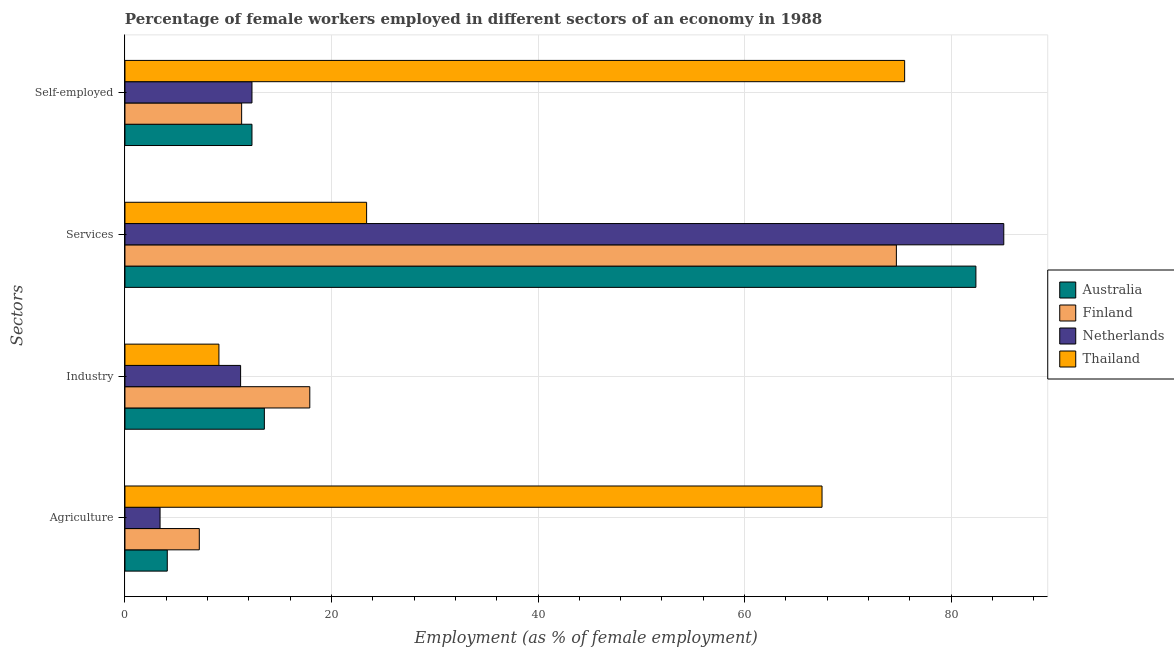Are the number of bars on each tick of the Y-axis equal?
Give a very brief answer. Yes. How many bars are there on the 4th tick from the top?
Give a very brief answer. 4. What is the label of the 2nd group of bars from the top?
Ensure brevity in your answer.  Services. What is the percentage of female workers in industry in Finland?
Keep it short and to the point. 17.9. Across all countries, what is the maximum percentage of self employed female workers?
Give a very brief answer. 75.5. Across all countries, what is the minimum percentage of self employed female workers?
Make the answer very short. 11.3. In which country was the percentage of self employed female workers maximum?
Keep it short and to the point. Thailand. What is the total percentage of self employed female workers in the graph?
Your answer should be very brief. 111.4. What is the difference between the percentage of female workers in services in Netherlands and that in Finland?
Your answer should be compact. 10.4. What is the difference between the percentage of female workers in agriculture in Australia and the percentage of female workers in industry in Thailand?
Provide a short and direct response. -5. What is the average percentage of self employed female workers per country?
Your answer should be compact. 27.85. What is the difference between the percentage of female workers in services and percentage of female workers in agriculture in Australia?
Offer a terse response. 78.3. What is the ratio of the percentage of female workers in agriculture in Australia to that in Finland?
Make the answer very short. 0.57. Is the percentage of female workers in industry in Australia less than that in Netherlands?
Keep it short and to the point. No. Is the difference between the percentage of self employed female workers in Australia and Netherlands greater than the difference between the percentage of female workers in agriculture in Australia and Netherlands?
Your answer should be compact. No. What is the difference between the highest and the second highest percentage of female workers in agriculture?
Give a very brief answer. 60.3. What is the difference between the highest and the lowest percentage of female workers in agriculture?
Offer a terse response. 64.1. Is it the case that in every country, the sum of the percentage of female workers in services and percentage of female workers in industry is greater than the sum of percentage of self employed female workers and percentage of female workers in agriculture?
Your response must be concise. Yes. What does the 3rd bar from the top in Services represents?
Ensure brevity in your answer.  Finland. What is the difference between two consecutive major ticks on the X-axis?
Provide a short and direct response. 20. Does the graph contain any zero values?
Offer a terse response. No. Does the graph contain grids?
Your answer should be compact. Yes. How many legend labels are there?
Give a very brief answer. 4. What is the title of the graph?
Provide a short and direct response. Percentage of female workers employed in different sectors of an economy in 1988. What is the label or title of the X-axis?
Offer a terse response. Employment (as % of female employment). What is the label or title of the Y-axis?
Your response must be concise. Sectors. What is the Employment (as % of female employment) of Australia in Agriculture?
Your answer should be very brief. 4.1. What is the Employment (as % of female employment) of Finland in Agriculture?
Make the answer very short. 7.2. What is the Employment (as % of female employment) of Netherlands in Agriculture?
Your answer should be compact. 3.4. What is the Employment (as % of female employment) in Thailand in Agriculture?
Offer a terse response. 67.5. What is the Employment (as % of female employment) of Finland in Industry?
Offer a very short reply. 17.9. What is the Employment (as % of female employment) of Netherlands in Industry?
Provide a succinct answer. 11.2. What is the Employment (as % of female employment) of Thailand in Industry?
Offer a terse response. 9.1. What is the Employment (as % of female employment) of Australia in Services?
Offer a terse response. 82.4. What is the Employment (as % of female employment) of Finland in Services?
Offer a very short reply. 74.7. What is the Employment (as % of female employment) in Netherlands in Services?
Your answer should be compact. 85.1. What is the Employment (as % of female employment) of Thailand in Services?
Your response must be concise. 23.4. What is the Employment (as % of female employment) of Australia in Self-employed?
Your answer should be compact. 12.3. What is the Employment (as % of female employment) of Finland in Self-employed?
Make the answer very short. 11.3. What is the Employment (as % of female employment) in Netherlands in Self-employed?
Offer a terse response. 12.3. What is the Employment (as % of female employment) of Thailand in Self-employed?
Your response must be concise. 75.5. Across all Sectors, what is the maximum Employment (as % of female employment) in Australia?
Give a very brief answer. 82.4. Across all Sectors, what is the maximum Employment (as % of female employment) in Finland?
Keep it short and to the point. 74.7. Across all Sectors, what is the maximum Employment (as % of female employment) of Netherlands?
Give a very brief answer. 85.1. Across all Sectors, what is the maximum Employment (as % of female employment) of Thailand?
Your answer should be compact. 75.5. Across all Sectors, what is the minimum Employment (as % of female employment) of Australia?
Ensure brevity in your answer.  4.1. Across all Sectors, what is the minimum Employment (as % of female employment) in Finland?
Offer a terse response. 7.2. Across all Sectors, what is the minimum Employment (as % of female employment) in Netherlands?
Ensure brevity in your answer.  3.4. Across all Sectors, what is the minimum Employment (as % of female employment) of Thailand?
Offer a very short reply. 9.1. What is the total Employment (as % of female employment) in Australia in the graph?
Provide a succinct answer. 112.3. What is the total Employment (as % of female employment) of Finland in the graph?
Ensure brevity in your answer.  111.1. What is the total Employment (as % of female employment) of Netherlands in the graph?
Offer a very short reply. 112. What is the total Employment (as % of female employment) in Thailand in the graph?
Provide a succinct answer. 175.5. What is the difference between the Employment (as % of female employment) in Australia in Agriculture and that in Industry?
Your answer should be compact. -9.4. What is the difference between the Employment (as % of female employment) in Finland in Agriculture and that in Industry?
Your answer should be compact. -10.7. What is the difference between the Employment (as % of female employment) of Thailand in Agriculture and that in Industry?
Offer a terse response. 58.4. What is the difference between the Employment (as % of female employment) of Australia in Agriculture and that in Services?
Provide a short and direct response. -78.3. What is the difference between the Employment (as % of female employment) in Finland in Agriculture and that in Services?
Provide a short and direct response. -67.5. What is the difference between the Employment (as % of female employment) in Netherlands in Agriculture and that in Services?
Provide a short and direct response. -81.7. What is the difference between the Employment (as % of female employment) of Thailand in Agriculture and that in Services?
Your answer should be very brief. 44.1. What is the difference between the Employment (as % of female employment) in Australia in Agriculture and that in Self-employed?
Your answer should be very brief. -8.2. What is the difference between the Employment (as % of female employment) in Finland in Agriculture and that in Self-employed?
Offer a terse response. -4.1. What is the difference between the Employment (as % of female employment) of Australia in Industry and that in Services?
Make the answer very short. -68.9. What is the difference between the Employment (as % of female employment) of Finland in Industry and that in Services?
Provide a short and direct response. -56.8. What is the difference between the Employment (as % of female employment) of Netherlands in Industry and that in Services?
Keep it short and to the point. -73.9. What is the difference between the Employment (as % of female employment) in Thailand in Industry and that in Services?
Offer a terse response. -14.3. What is the difference between the Employment (as % of female employment) in Finland in Industry and that in Self-employed?
Make the answer very short. 6.6. What is the difference between the Employment (as % of female employment) of Netherlands in Industry and that in Self-employed?
Provide a succinct answer. -1.1. What is the difference between the Employment (as % of female employment) in Thailand in Industry and that in Self-employed?
Provide a short and direct response. -66.4. What is the difference between the Employment (as % of female employment) of Australia in Services and that in Self-employed?
Your answer should be very brief. 70.1. What is the difference between the Employment (as % of female employment) of Finland in Services and that in Self-employed?
Offer a very short reply. 63.4. What is the difference between the Employment (as % of female employment) of Netherlands in Services and that in Self-employed?
Keep it short and to the point. 72.8. What is the difference between the Employment (as % of female employment) in Thailand in Services and that in Self-employed?
Your answer should be compact. -52.1. What is the difference between the Employment (as % of female employment) in Australia in Agriculture and the Employment (as % of female employment) in Netherlands in Industry?
Provide a succinct answer. -7.1. What is the difference between the Employment (as % of female employment) of Australia in Agriculture and the Employment (as % of female employment) of Thailand in Industry?
Offer a terse response. -5. What is the difference between the Employment (as % of female employment) of Finland in Agriculture and the Employment (as % of female employment) of Netherlands in Industry?
Your response must be concise. -4. What is the difference between the Employment (as % of female employment) of Finland in Agriculture and the Employment (as % of female employment) of Thailand in Industry?
Provide a short and direct response. -1.9. What is the difference between the Employment (as % of female employment) in Australia in Agriculture and the Employment (as % of female employment) in Finland in Services?
Your answer should be very brief. -70.6. What is the difference between the Employment (as % of female employment) of Australia in Agriculture and the Employment (as % of female employment) of Netherlands in Services?
Make the answer very short. -81. What is the difference between the Employment (as % of female employment) of Australia in Agriculture and the Employment (as % of female employment) of Thailand in Services?
Your answer should be very brief. -19.3. What is the difference between the Employment (as % of female employment) of Finland in Agriculture and the Employment (as % of female employment) of Netherlands in Services?
Your answer should be compact. -77.9. What is the difference between the Employment (as % of female employment) in Finland in Agriculture and the Employment (as % of female employment) in Thailand in Services?
Offer a terse response. -16.2. What is the difference between the Employment (as % of female employment) of Australia in Agriculture and the Employment (as % of female employment) of Finland in Self-employed?
Your answer should be very brief. -7.2. What is the difference between the Employment (as % of female employment) of Australia in Agriculture and the Employment (as % of female employment) of Netherlands in Self-employed?
Give a very brief answer. -8.2. What is the difference between the Employment (as % of female employment) of Australia in Agriculture and the Employment (as % of female employment) of Thailand in Self-employed?
Your answer should be compact. -71.4. What is the difference between the Employment (as % of female employment) in Finland in Agriculture and the Employment (as % of female employment) in Thailand in Self-employed?
Provide a succinct answer. -68.3. What is the difference between the Employment (as % of female employment) of Netherlands in Agriculture and the Employment (as % of female employment) of Thailand in Self-employed?
Offer a terse response. -72.1. What is the difference between the Employment (as % of female employment) of Australia in Industry and the Employment (as % of female employment) of Finland in Services?
Ensure brevity in your answer.  -61.2. What is the difference between the Employment (as % of female employment) in Australia in Industry and the Employment (as % of female employment) in Netherlands in Services?
Make the answer very short. -71.6. What is the difference between the Employment (as % of female employment) of Finland in Industry and the Employment (as % of female employment) of Netherlands in Services?
Provide a short and direct response. -67.2. What is the difference between the Employment (as % of female employment) of Finland in Industry and the Employment (as % of female employment) of Thailand in Services?
Offer a very short reply. -5.5. What is the difference between the Employment (as % of female employment) of Australia in Industry and the Employment (as % of female employment) of Netherlands in Self-employed?
Your answer should be very brief. 1.2. What is the difference between the Employment (as % of female employment) in Australia in Industry and the Employment (as % of female employment) in Thailand in Self-employed?
Offer a terse response. -62. What is the difference between the Employment (as % of female employment) in Finland in Industry and the Employment (as % of female employment) in Netherlands in Self-employed?
Give a very brief answer. 5.6. What is the difference between the Employment (as % of female employment) in Finland in Industry and the Employment (as % of female employment) in Thailand in Self-employed?
Provide a short and direct response. -57.6. What is the difference between the Employment (as % of female employment) in Netherlands in Industry and the Employment (as % of female employment) in Thailand in Self-employed?
Give a very brief answer. -64.3. What is the difference between the Employment (as % of female employment) of Australia in Services and the Employment (as % of female employment) of Finland in Self-employed?
Your answer should be compact. 71.1. What is the difference between the Employment (as % of female employment) of Australia in Services and the Employment (as % of female employment) of Netherlands in Self-employed?
Your response must be concise. 70.1. What is the difference between the Employment (as % of female employment) in Finland in Services and the Employment (as % of female employment) in Netherlands in Self-employed?
Your answer should be compact. 62.4. What is the average Employment (as % of female employment) in Australia per Sectors?
Give a very brief answer. 28.07. What is the average Employment (as % of female employment) in Finland per Sectors?
Provide a succinct answer. 27.77. What is the average Employment (as % of female employment) in Thailand per Sectors?
Your response must be concise. 43.88. What is the difference between the Employment (as % of female employment) of Australia and Employment (as % of female employment) of Finland in Agriculture?
Your response must be concise. -3.1. What is the difference between the Employment (as % of female employment) of Australia and Employment (as % of female employment) of Thailand in Agriculture?
Your response must be concise. -63.4. What is the difference between the Employment (as % of female employment) in Finland and Employment (as % of female employment) in Thailand in Agriculture?
Ensure brevity in your answer.  -60.3. What is the difference between the Employment (as % of female employment) of Netherlands and Employment (as % of female employment) of Thailand in Agriculture?
Your answer should be compact. -64.1. What is the difference between the Employment (as % of female employment) in Australia and Employment (as % of female employment) in Finland in Industry?
Provide a succinct answer. -4.4. What is the difference between the Employment (as % of female employment) of Australia and Employment (as % of female employment) of Netherlands in Services?
Give a very brief answer. -2.7. What is the difference between the Employment (as % of female employment) in Australia and Employment (as % of female employment) in Thailand in Services?
Your answer should be very brief. 59. What is the difference between the Employment (as % of female employment) in Finland and Employment (as % of female employment) in Thailand in Services?
Give a very brief answer. 51.3. What is the difference between the Employment (as % of female employment) of Netherlands and Employment (as % of female employment) of Thailand in Services?
Your answer should be very brief. 61.7. What is the difference between the Employment (as % of female employment) of Australia and Employment (as % of female employment) of Thailand in Self-employed?
Offer a terse response. -63.2. What is the difference between the Employment (as % of female employment) in Finland and Employment (as % of female employment) in Netherlands in Self-employed?
Keep it short and to the point. -1. What is the difference between the Employment (as % of female employment) in Finland and Employment (as % of female employment) in Thailand in Self-employed?
Offer a terse response. -64.2. What is the difference between the Employment (as % of female employment) in Netherlands and Employment (as % of female employment) in Thailand in Self-employed?
Offer a terse response. -63.2. What is the ratio of the Employment (as % of female employment) in Australia in Agriculture to that in Industry?
Give a very brief answer. 0.3. What is the ratio of the Employment (as % of female employment) of Finland in Agriculture to that in Industry?
Offer a terse response. 0.4. What is the ratio of the Employment (as % of female employment) in Netherlands in Agriculture to that in Industry?
Your response must be concise. 0.3. What is the ratio of the Employment (as % of female employment) in Thailand in Agriculture to that in Industry?
Provide a succinct answer. 7.42. What is the ratio of the Employment (as % of female employment) in Australia in Agriculture to that in Services?
Provide a short and direct response. 0.05. What is the ratio of the Employment (as % of female employment) of Finland in Agriculture to that in Services?
Make the answer very short. 0.1. What is the ratio of the Employment (as % of female employment) of Netherlands in Agriculture to that in Services?
Keep it short and to the point. 0.04. What is the ratio of the Employment (as % of female employment) of Thailand in Agriculture to that in Services?
Provide a succinct answer. 2.88. What is the ratio of the Employment (as % of female employment) of Australia in Agriculture to that in Self-employed?
Offer a very short reply. 0.33. What is the ratio of the Employment (as % of female employment) in Finland in Agriculture to that in Self-employed?
Ensure brevity in your answer.  0.64. What is the ratio of the Employment (as % of female employment) in Netherlands in Agriculture to that in Self-employed?
Your response must be concise. 0.28. What is the ratio of the Employment (as % of female employment) in Thailand in Agriculture to that in Self-employed?
Your answer should be very brief. 0.89. What is the ratio of the Employment (as % of female employment) in Australia in Industry to that in Services?
Provide a short and direct response. 0.16. What is the ratio of the Employment (as % of female employment) of Finland in Industry to that in Services?
Provide a succinct answer. 0.24. What is the ratio of the Employment (as % of female employment) in Netherlands in Industry to that in Services?
Give a very brief answer. 0.13. What is the ratio of the Employment (as % of female employment) of Thailand in Industry to that in Services?
Provide a succinct answer. 0.39. What is the ratio of the Employment (as % of female employment) of Australia in Industry to that in Self-employed?
Make the answer very short. 1.1. What is the ratio of the Employment (as % of female employment) in Finland in Industry to that in Self-employed?
Offer a terse response. 1.58. What is the ratio of the Employment (as % of female employment) in Netherlands in Industry to that in Self-employed?
Offer a terse response. 0.91. What is the ratio of the Employment (as % of female employment) of Thailand in Industry to that in Self-employed?
Ensure brevity in your answer.  0.12. What is the ratio of the Employment (as % of female employment) in Australia in Services to that in Self-employed?
Provide a succinct answer. 6.7. What is the ratio of the Employment (as % of female employment) in Finland in Services to that in Self-employed?
Make the answer very short. 6.61. What is the ratio of the Employment (as % of female employment) of Netherlands in Services to that in Self-employed?
Offer a very short reply. 6.92. What is the ratio of the Employment (as % of female employment) of Thailand in Services to that in Self-employed?
Provide a short and direct response. 0.31. What is the difference between the highest and the second highest Employment (as % of female employment) in Australia?
Offer a very short reply. 68.9. What is the difference between the highest and the second highest Employment (as % of female employment) of Finland?
Your answer should be very brief. 56.8. What is the difference between the highest and the second highest Employment (as % of female employment) in Netherlands?
Offer a terse response. 72.8. What is the difference between the highest and the lowest Employment (as % of female employment) of Australia?
Give a very brief answer. 78.3. What is the difference between the highest and the lowest Employment (as % of female employment) in Finland?
Keep it short and to the point. 67.5. What is the difference between the highest and the lowest Employment (as % of female employment) in Netherlands?
Offer a very short reply. 81.7. What is the difference between the highest and the lowest Employment (as % of female employment) of Thailand?
Provide a succinct answer. 66.4. 